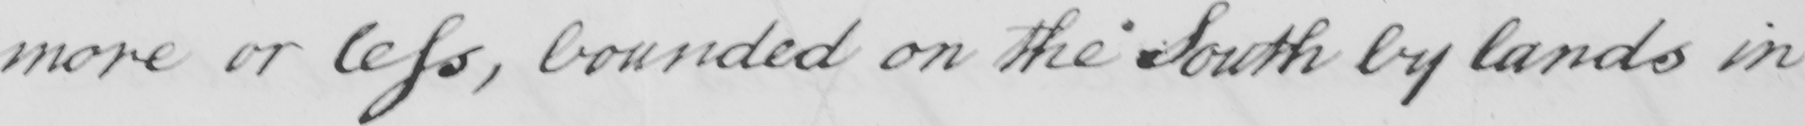Can you tell me what this handwritten text says? more or less , bounded on the South by lands in 